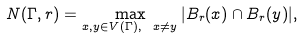<formula> <loc_0><loc_0><loc_500><loc_500>N ( \Gamma , r ) = \max _ { x , y \in V ( \Gamma ) , \ x \neq y } | B _ { r } ( x ) \cap B _ { r } ( y ) | ,</formula> 